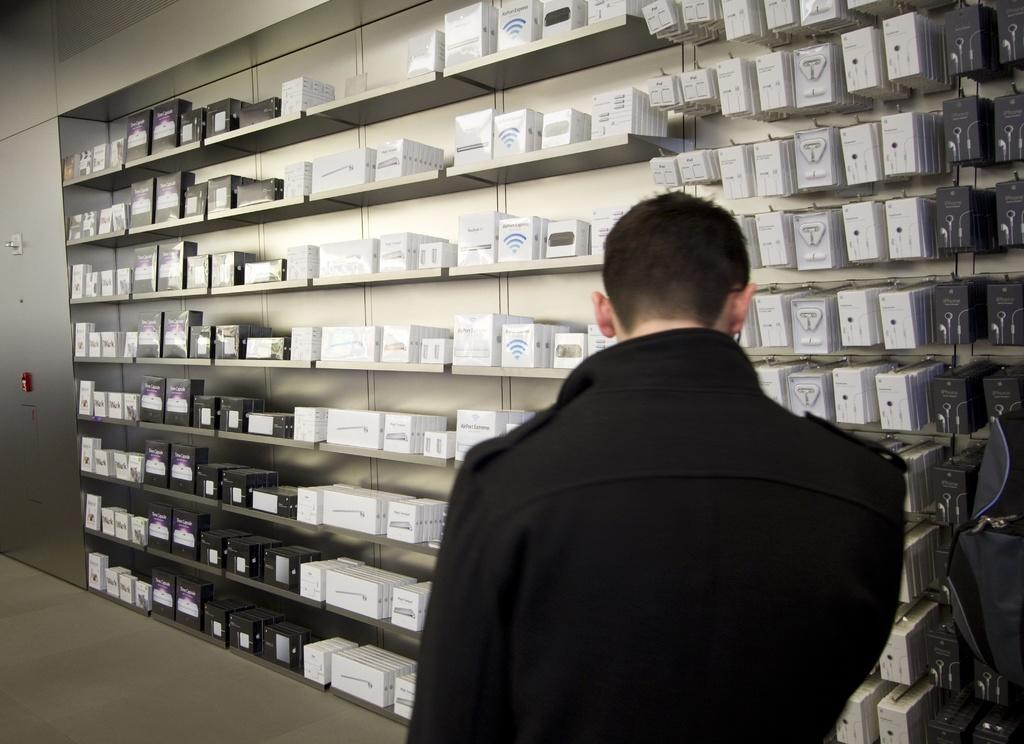What is the person in the foreground of the image wearing? The person in the foreground of the image is wearing a black jacket. What can be seen in the middle of the image? Electronic gadgets are placed in racks in the middle of the image. Can you describe the possible feature on the left side of the image? There might be a door on the left side of the image. What type of sticks are being used to manipulate the electronic gadgets in the image? There are no sticks visible in the image, and the electronic gadgets are not being manipulated. 